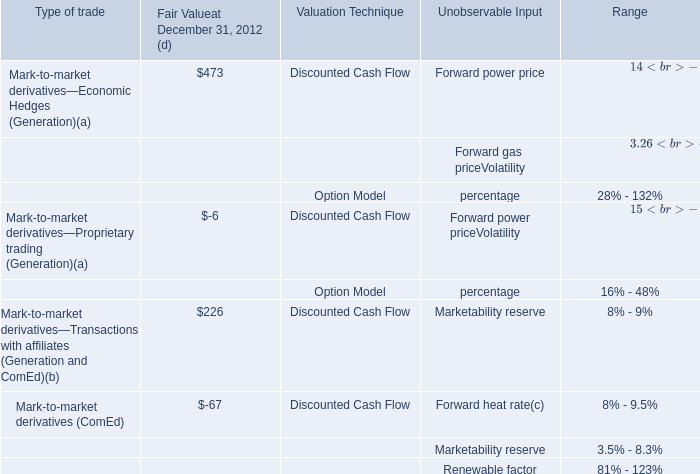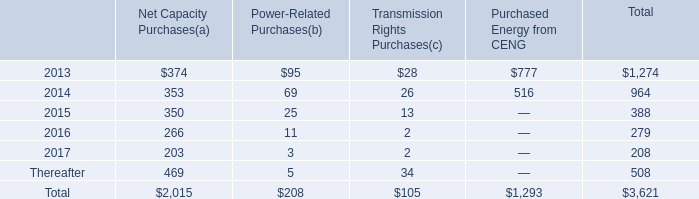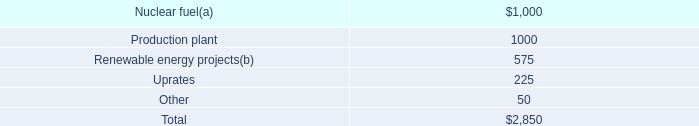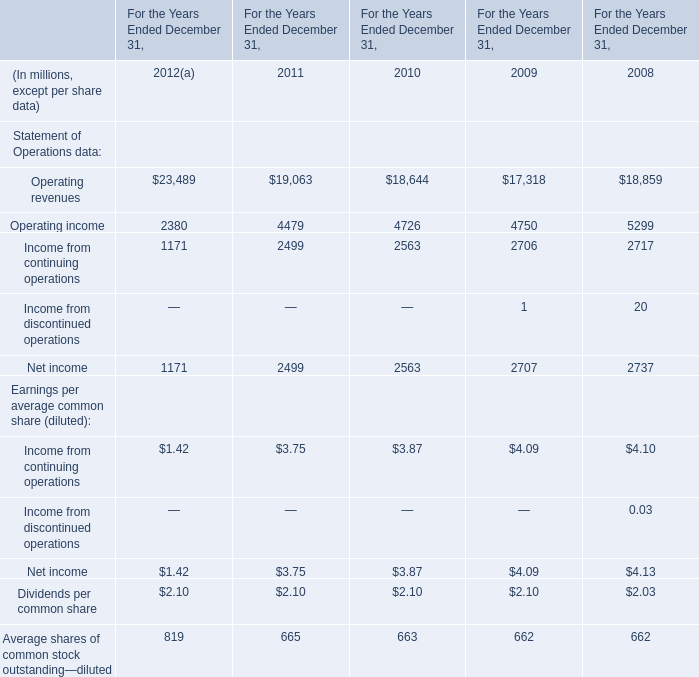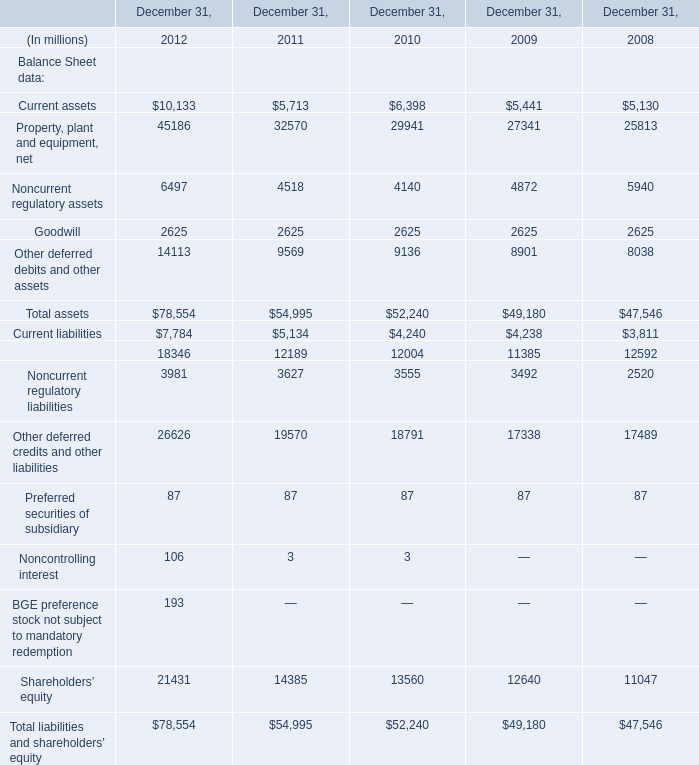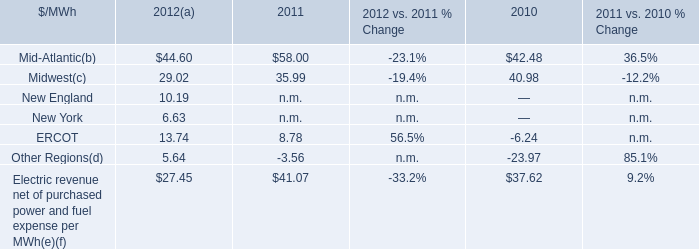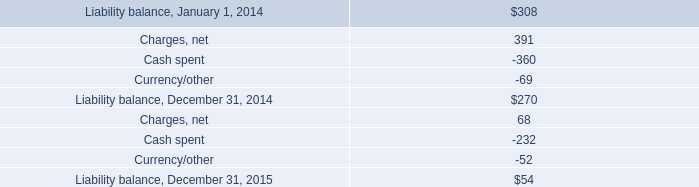What is the total amount of Net income of For the Years Ended December 31, 2011, and Other deferred credits and other liabilities of December 31, 2008 ? 
Computations: (2499.0 + 17489.0)
Answer: 19988.0. 